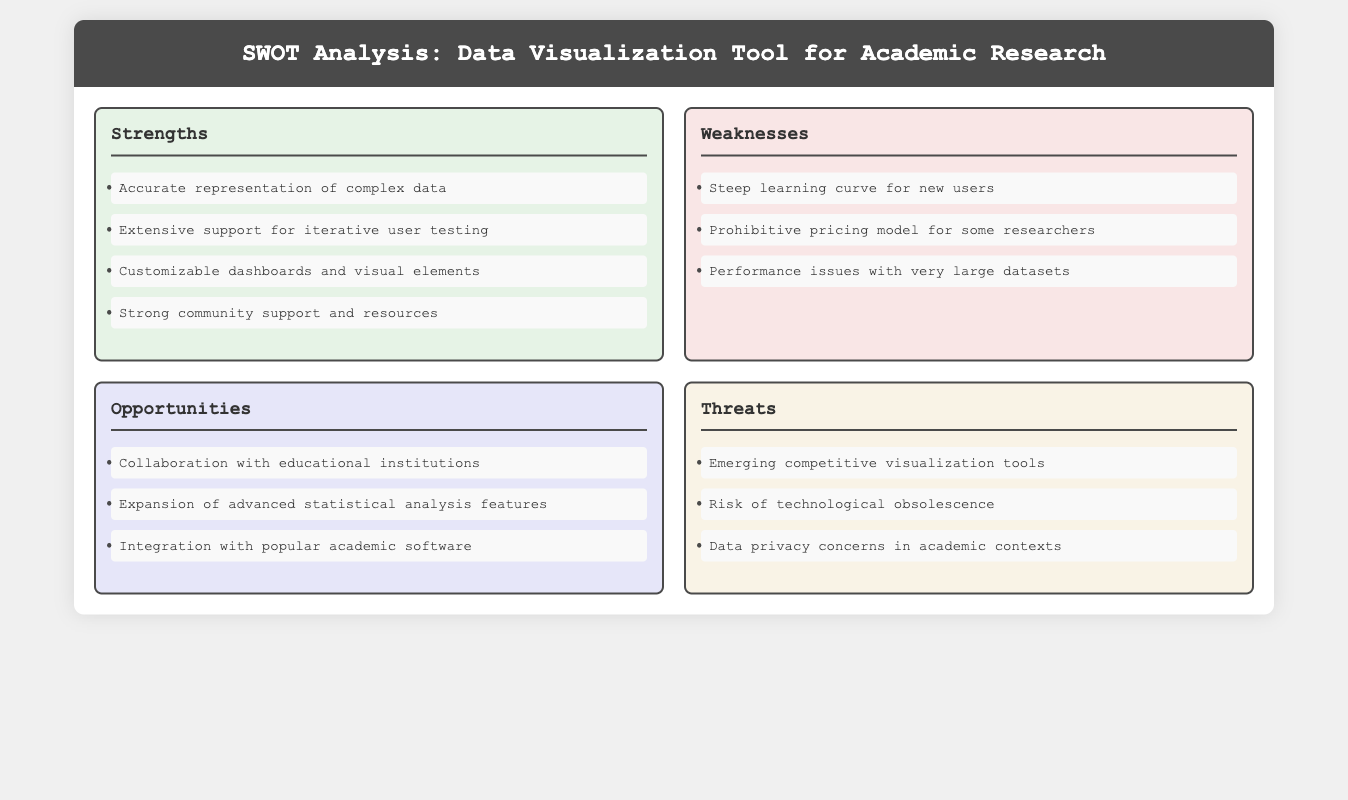what is one strength of the tool? The strengths section lists several strengths, which include accurate representation of complex data.
Answer: accurate representation of complex data what is a weakness mentioned in the analysis? The weaknesses section outlines several weaknesses, one of which is the steep learning curve for new users.
Answer: steep learning curve for new users how many opportunities are listed in the document? The opportunities section features three items that express potential areas for growth or improvement.
Answer: three what is one potential threat identified? The threats section includes various threats, one of which is emerging competitive visualization tools.
Answer: emerging competitive visualization tools which area focuses on customization? The strengths section mentions customizable dashboards and visual elements, highlighting it as a focus area.
Answer: strengths what does the document suggest could enhance the tool? The opportunities section indicates that collaboration with educational institutions could enhance the tool.
Answer: collaboration with educational institutions what is the color used for the weaknesses section? The weaknesses section is indicated by a specific background color design, which is a light pinkish shade.
Answer: light pinkish shade how does community support rank among strengths? Community support is listed as one of the four strengths, suggesting it is considered a significant advantage.
Answer: significant advantage what kind of issues might the tool face with large data? The weaknesses section mentions performance issues with very large datasets, indicating a concern in this area.
Answer: performance issues with very large datasets 